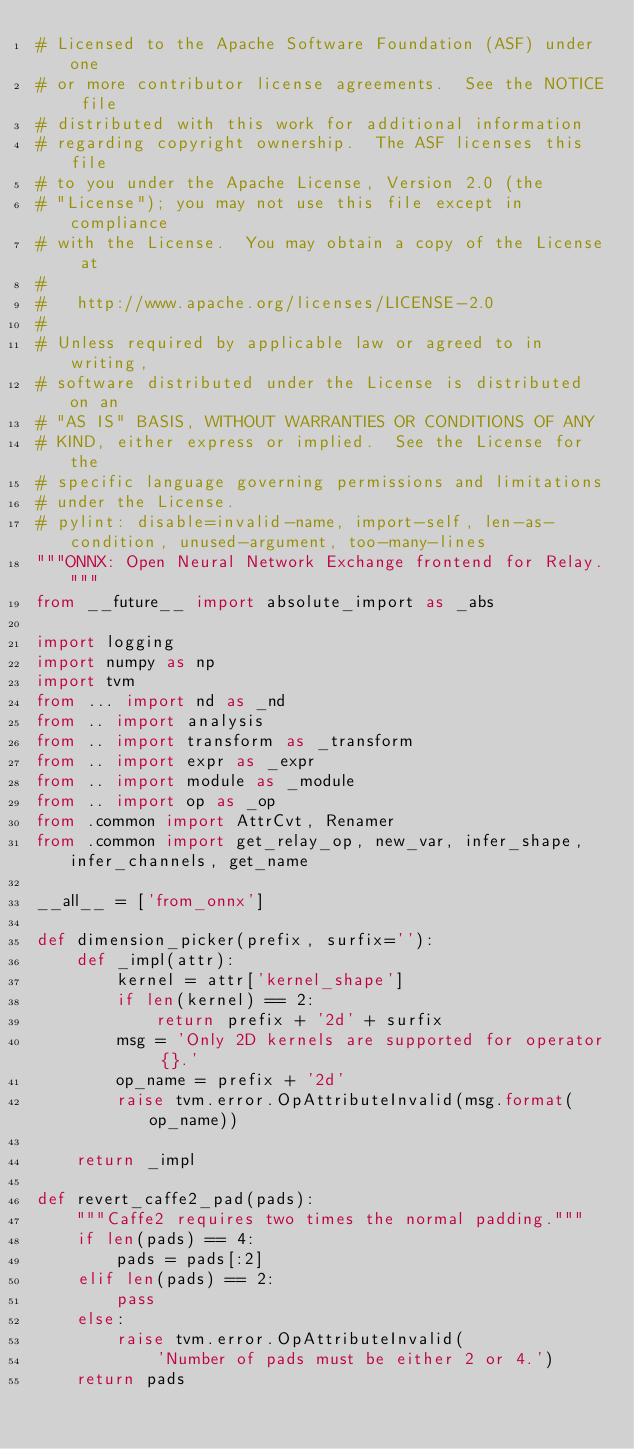Convert code to text. <code><loc_0><loc_0><loc_500><loc_500><_Python_># Licensed to the Apache Software Foundation (ASF) under one
# or more contributor license agreements.  See the NOTICE file
# distributed with this work for additional information
# regarding copyright ownership.  The ASF licenses this file
# to you under the Apache License, Version 2.0 (the
# "License"); you may not use this file except in compliance
# with the License.  You may obtain a copy of the License at
#
#   http://www.apache.org/licenses/LICENSE-2.0
#
# Unless required by applicable law or agreed to in writing,
# software distributed under the License is distributed on an
# "AS IS" BASIS, WITHOUT WARRANTIES OR CONDITIONS OF ANY
# KIND, either express or implied.  See the License for the
# specific language governing permissions and limitations
# under the License.
# pylint: disable=invalid-name, import-self, len-as-condition, unused-argument, too-many-lines
"""ONNX: Open Neural Network Exchange frontend for Relay."""
from __future__ import absolute_import as _abs

import logging
import numpy as np
import tvm
from ... import nd as _nd
from .. import analysis
from .. import transform as _transform
from .. import expr as _expr
from .. import module as _module
from .. import op as _op
from .common import AttrCvt, Renamer
from .common import get_relay_op, new_var, infer_shape, infer_channels, get_name

__all__ = ['from_onnx']

def dimension_picker(prefix, surfix=''):
    def _impl(attr):
        kernel = attr['kernel_shape']
        if len(kernel) == 2:
            return prefix + '2d' + surfix
        msg = 'Only 2D kernels are supported for operator {}.'
        op_name = prefix + '2d'
        raise tvm.error.OpAttributeInvalid(msg.format(op_name))

    return _impl

def revert_caffe2_pad(pads):
    """Caffe2 requires two times the normal padding."""
    if len(pads) == 4:
        pads = pads[:2]
    elif len(pads) == 2:
        pass
    else:
        raise tvm.error.OpAttributeInvalid(
            'Number of pads must be either 2 or 4.')
    return pads

</code> 